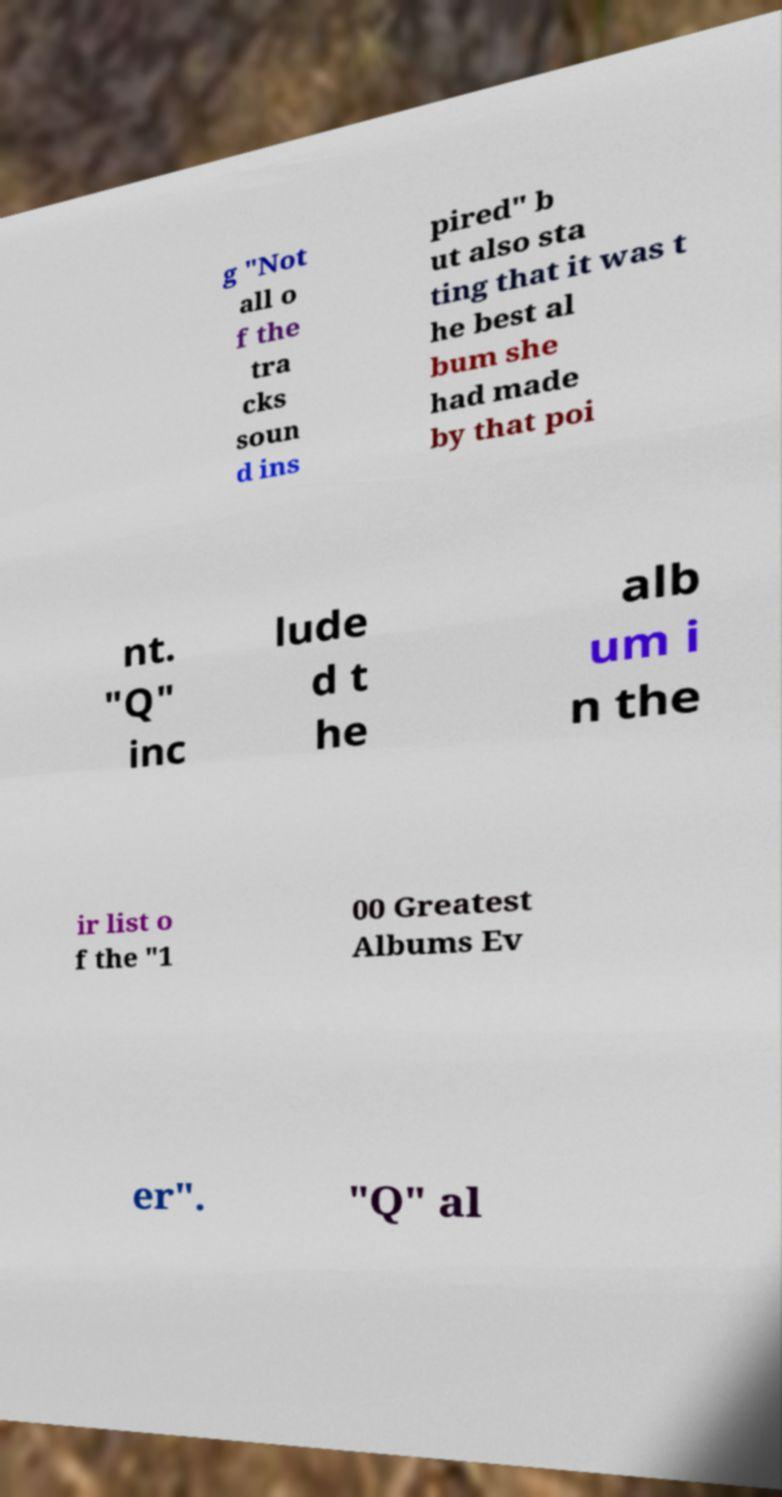Can you read and provide the text displayed in the image?This photo seems to have some interesting text. Can you extract and type it out for me? g "Not all o f the tra cks soun d ins pired" b ut also sta ting that it was t he best al bum she had made by that poi nt. "Q" inc lude d t he alb um i n the ir list o f the "1 00 Greatest Albums Ev er". "Q" al 